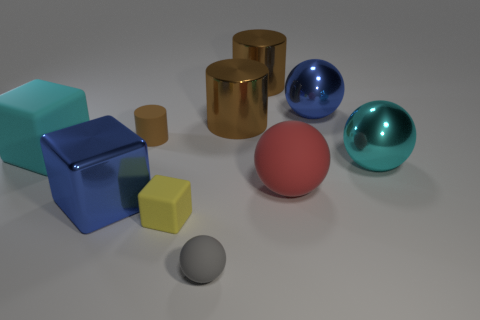Are there any patterns or consistencies in the arrangement of the objects? The objects seem to be arranged with some intent, although not following a strict pattern. They are spaced relatively evenly across the surface with varying shapes and colors, suggesting an arranged diversity rather than a uniform pattern. 